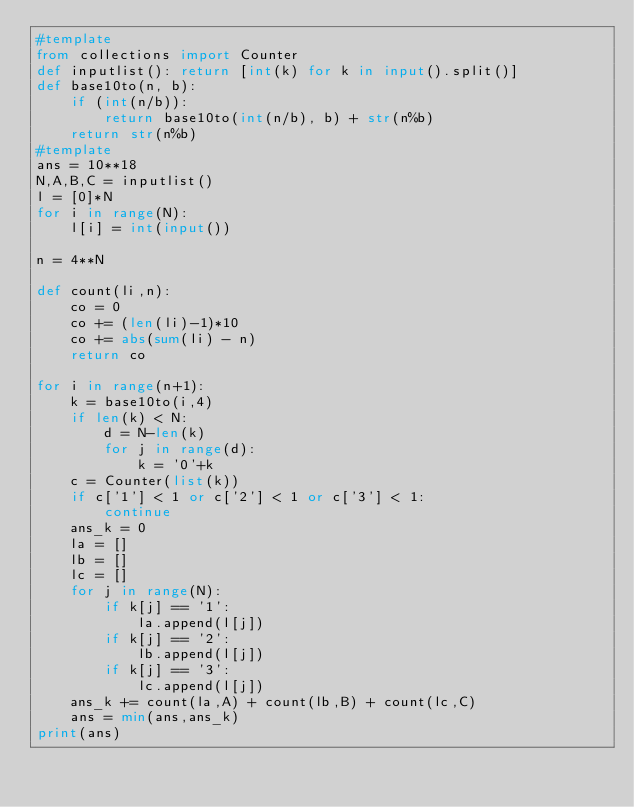Convert code to text. <code><loc_0><loc_0><loc_500><loc_500><_Python_>#template
from collections import Counter
def inputlist(): return [int(k) for k in input().split()]
def base10to(n, b):
    if (int(n/b)):
        return base10to(int(n/b), b) + str(n%b)
    return str(n%b)
#template
ans = 10**18
N,A,B,C = inputlist()
l = [0]*N
for i in range(N):
    l[i] = int(input())

n = 4**N

def count(li,n):
    co = 0
    co += (len(li)-1)*10
    co += abs(sum(li) - n)
    return co

for i in range(n+1):
    k = base10to(i,4)
    if len(k) < N:
        d = N-len(k)
        for j in range(d):
            k = '0'+k
    c = Counter(list(k))
    if c['1'] < 1 or c['2'] < 1 or c['3'] < 1:
        continue
    ans_k = 0
    la = []
    lb = []
    lc = []
    for j in range(N):
        if k[j] == '1':
            la.append(l[j])
        if k[j] == '2':
            lb.append(l[j])
        if k[j] == '3':
            lc.append(l[j])
    ans_k += count(la,A) + count(lb,B) + count(lc,C)
    ans = min(ans,ans_k)
print(ans)</code> 